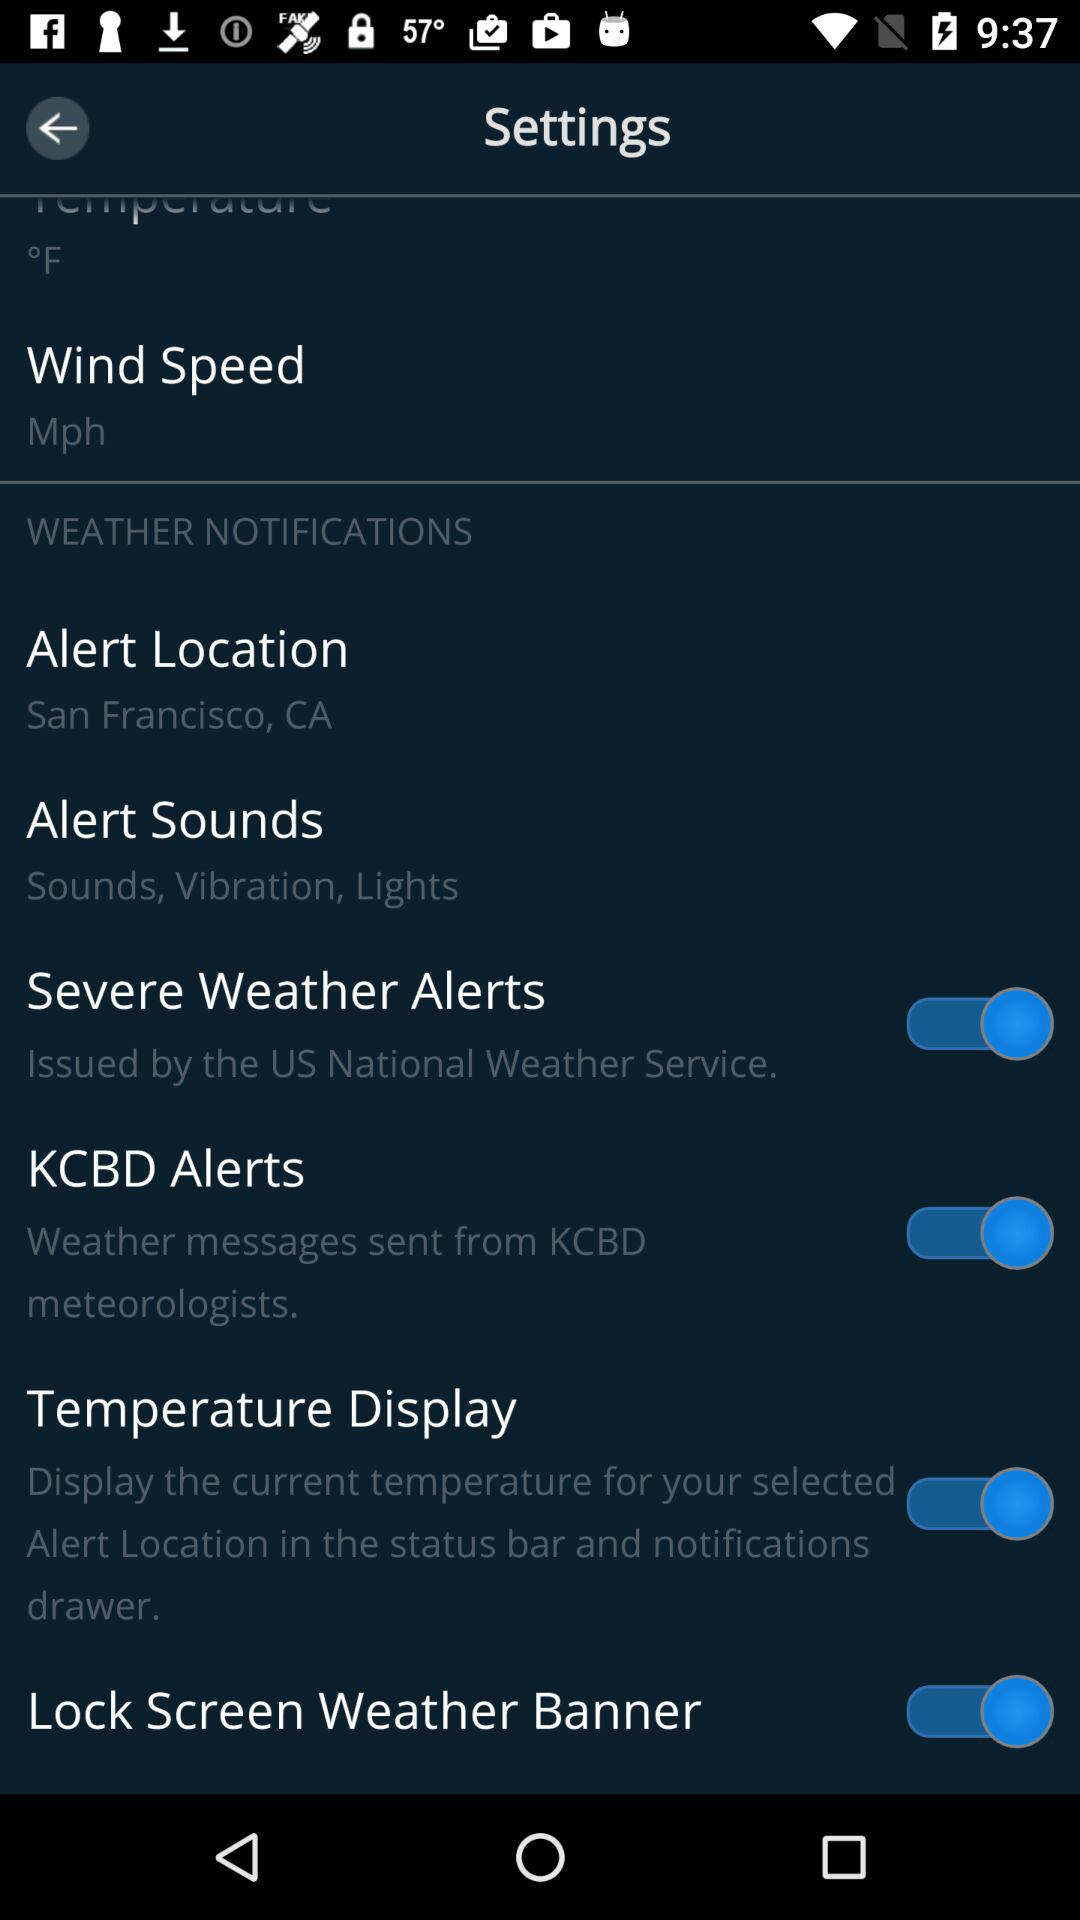What institute issued the "Severe Weather Alerts"?It It's issued by the "US National Weather Service". 